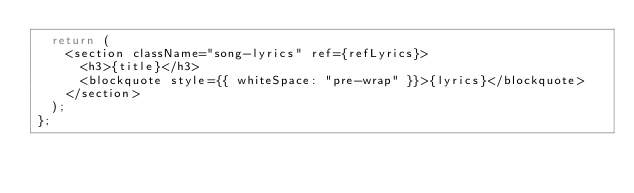<code> <loc_0><loc_0><loc_500><loc_500><_JavaScript_>  return (
    <section className="song-lyrics" ref={refLyrics}>
      <h3>{title}</h3>
      <blockquote style={{ whiteSpace: "pre-wrap" }}>{lyrics}</blockquote>
    </section>
  );
};
</code> 